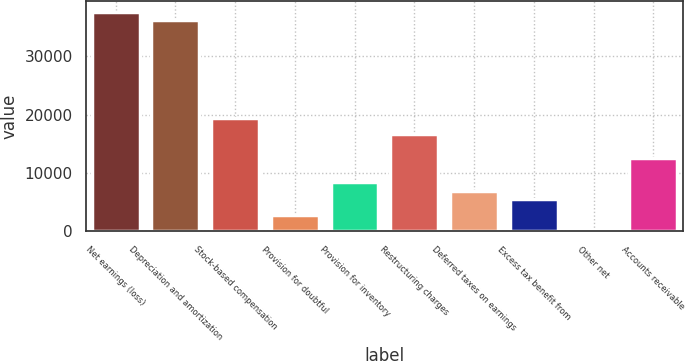<chart> <loc_0><loc_0><loc_500><loc_500><bar_chart><fcel>Net earnings (loss)<fcel>Depreciation and amortization<fcel>Stock-based compensation<fcel>Provision for doubtful<fcel>Provision for inventory<fcel>Restructuring charges<fcel>Deferred taxes on earnings<fcel>Excess tax benefit from<fcel>Other net<fcel>Accounts receivable<nl><fcel>37611.1<fcel>36219.8<fcel>19524.2<fcel>2828.6<fcel>8393.8<fcel>16741.6<fcel>7002.5<fcel>5611.2<fcel>46<fcel>12567.7<nl></chart> 